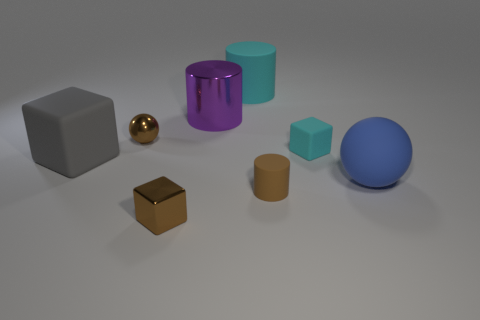There is a brown metal object that is in front of the big matte sphere; what is its shape?
Ensure brevity in your answer.  Cube. Is the gray object the same shape as the large cyan rubber thing?
Your answer should be very brief. No. Are there an equal number of cyan rubber cubes in front of the brown shiny cube and big red cubes?
Give a very brief answer. Yes. There is a large purple object; what shape is it?
Give a very brief answer. Cylinder. Is there any other thing of the same color as the big block?
Your answer should be very brief. No. There is a brown object behind the big gray thing; is it the same size as the block that is in front of the small cylinder?
Make the answer very short. Yes. What shape is the brown metal object that is to the right of the sphere that is to the left of the purple cylinder?
Ensure brevity in your answer.  Cube. Is the size of the brown cylinder the same as the brown cube in front of the cyan cylinder?
Your answer should be very brief. Yes. What is the size of the shiny thing that is on the left side of the brown object in front of the matte cylinder that is in front of the tiny brown metallic sphere?
Your response must be concise. Small. What number of objects are things behind the tiny metallic ball or blue balls?
Your answer should be very brief. 3. 